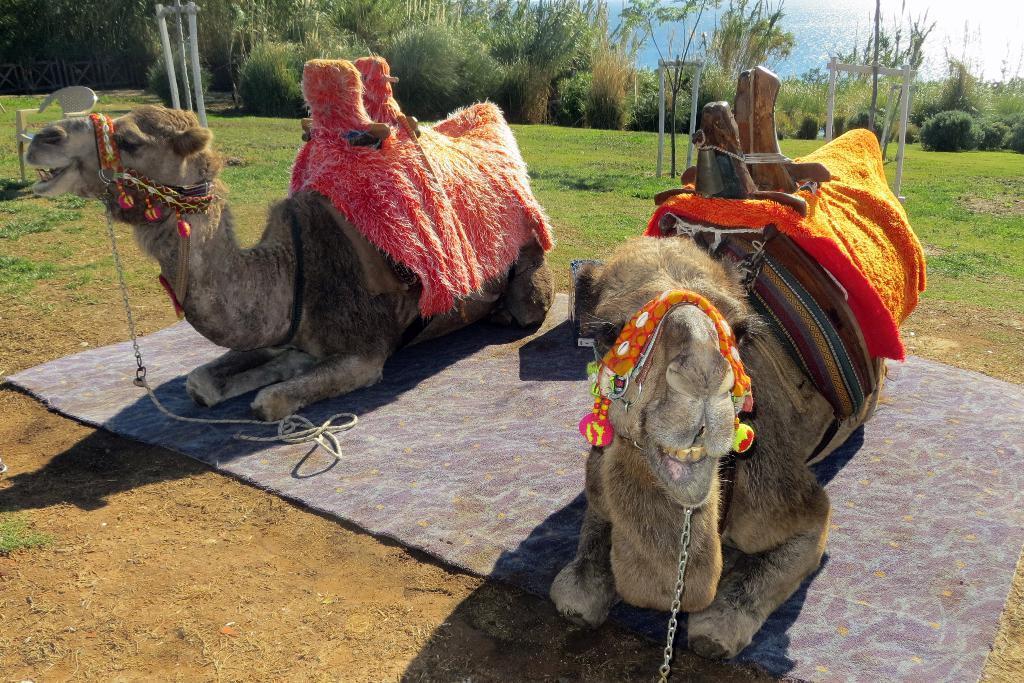How would you summarize this image in a sentence or two? In this picture I can see couple of camels on the carpet and I can see clothes on the camels and in the back I can see trees, water and grass on the ground and a chair on the left side of the picture. 